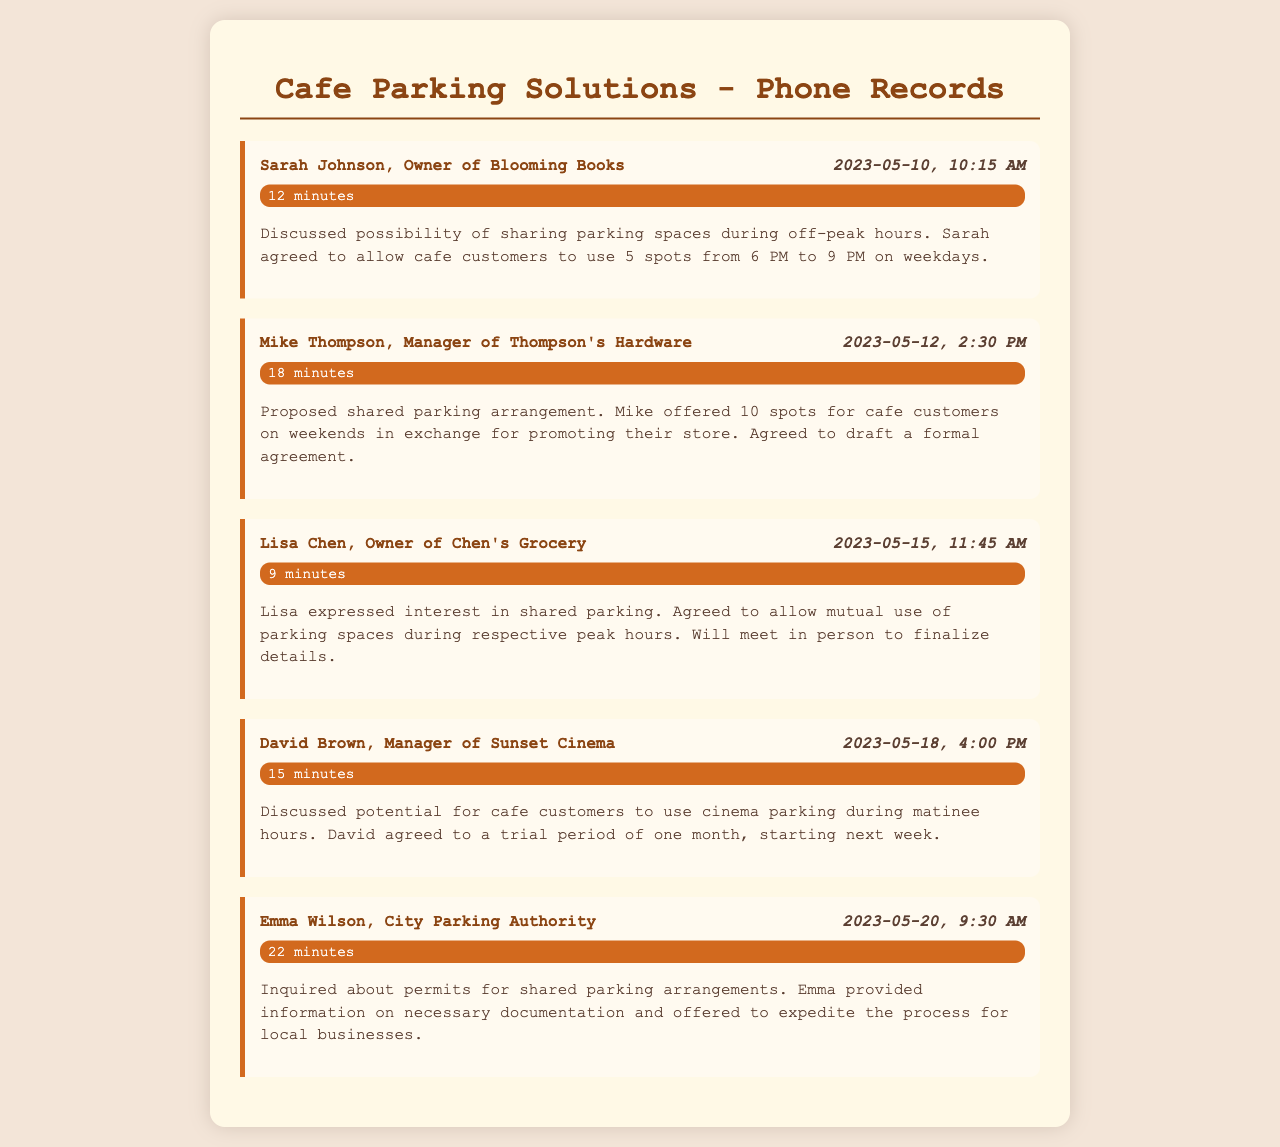What is the name of the business owner who discussed parking with you on May 10? The record states that the call was with Sarah Johnson, the owner of Blooming Books.
Answer: Sarah Johnson How many parking spots did Sarah agree to allow for cafe customers? The summary indicates that Sarah agreed to allow 5 spots for cafe customers.
Answer: 5 spots On what date did you call the City Parking Authority? The record shows the call date with Emma Wilson was on May 20.
Answer: May 20 What was the duration of the call with Mike Thompson? The document lists that the duration of the call with Mike was 18 minutes.
Answer: 18 minutes What arrangement did David Brown agree to for trial? The summary notes that David agreed to a trial period for cafe customers to use cinema parking during matinee hours.
Answer: Trial period How many parking spots did Mike offer for the cafe customers? The conversation with Mike mentions that he offered 10 spots for cafe customers.
Answer: 10 spots What time frame did Sarah agree upon for shared parking? The record specifies that the shared parking time frame is from 6 PM to 9 PM on weekdays.
Answer: 6 PM to 9 PM Who did you talk to about permits for shared parking? The document states you spoke with Emma Wilson from the City Parking Authority regarding permits.
Answer: Emma Wilson What was discussed regarding mutual use of parking spaces with Lisa? The summary indicates an agreement for mutual use during respective peak hours.
Answer: Mutual use during respective peak hours 